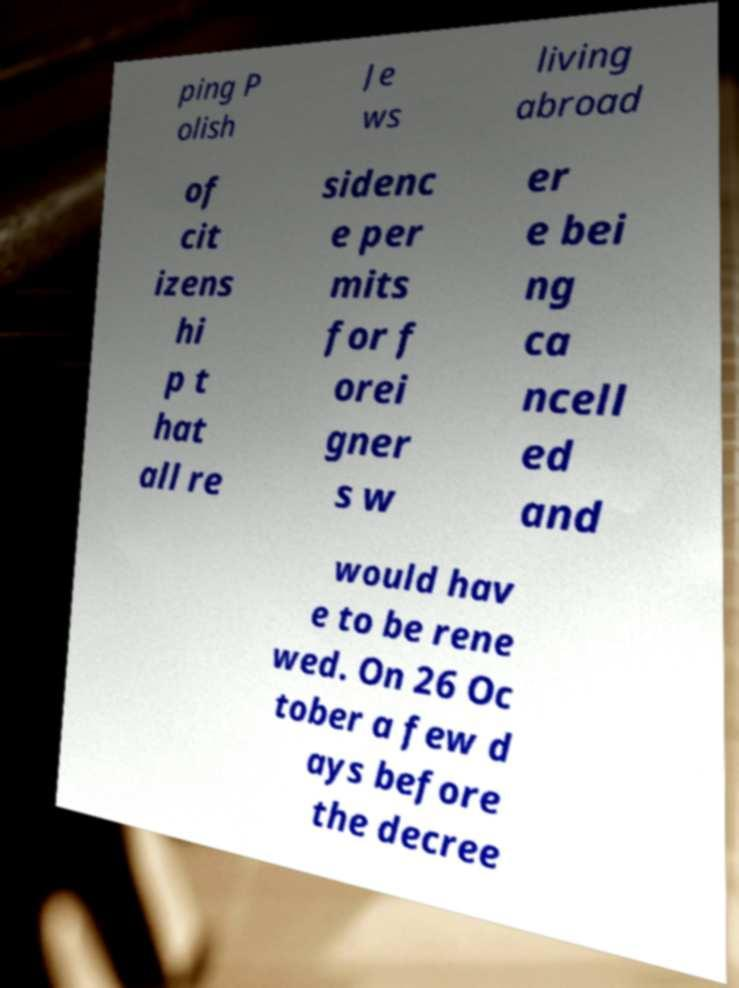Please read and relay the text visible in this image. What does it say? ping P olish Je ws living abroad of cit izens hi p t hat all re sidenc e per mits for f orei gner s w er e bei ng ca ncell ed and would hav e to be rene wed. On 26 Oc tober a few d ays before the decree 